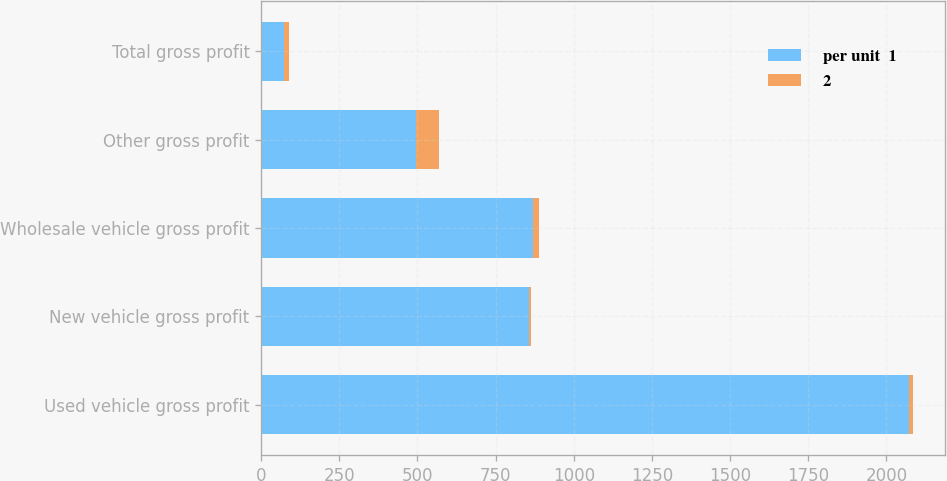Convert chart. <chart><loc_0><loc_0><loc_500><loc_500><stacked_bar_chart><ecel><fcel>Used vehicle gross profit<fcel>New vehicle gross profit<fcel>Wholesale vehicle gross profit<fcel>Other gross profit<fcel>Total gross profit<nl><fcel>per unit  1<fcel>2072<fcel>858<fcel>869<fcel>495<fcel>73.3<nl><fcel>2<fcel>11.9<fcel>3.6<fcel>20.3<fcel>73.3<fcel>14.7<nl></chart> 